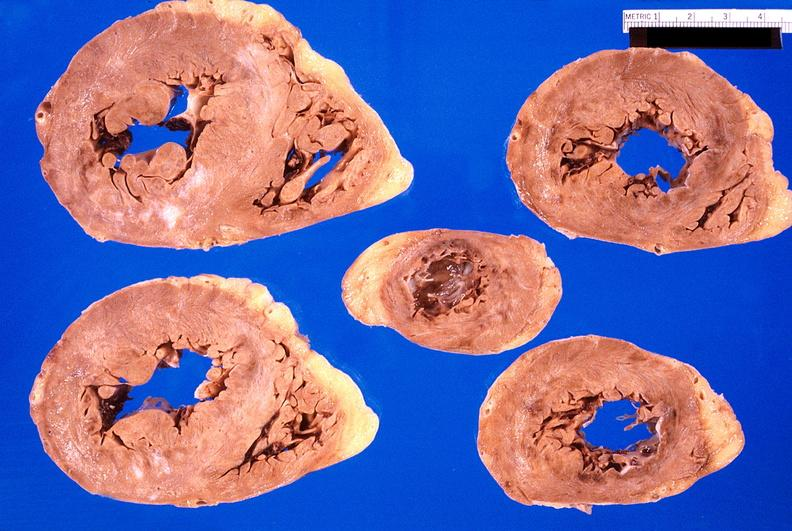what does this image show?
Answer the question using a single word or phrase. Heart 